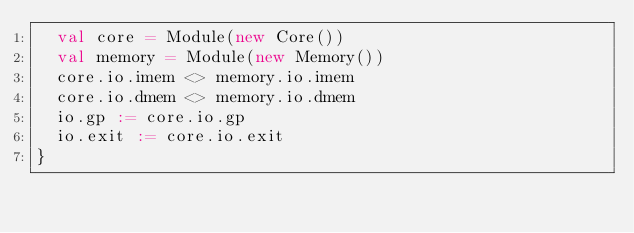<code> <loc_0><loc_0><loc_500><loc_500><_Scala_>  val core = Module(new Core())
  val memory = Module(new Memory())
  core.io.imem <> memory.io.imem
  core.io.dmem <> memory.io.dmem
  io.gp := core.io.gp
  io.exit := core.io.exit
}</code> 